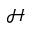<formula> <loc_0><loc_0><loc_500><loc_500>\mathcal { H }</formula> 